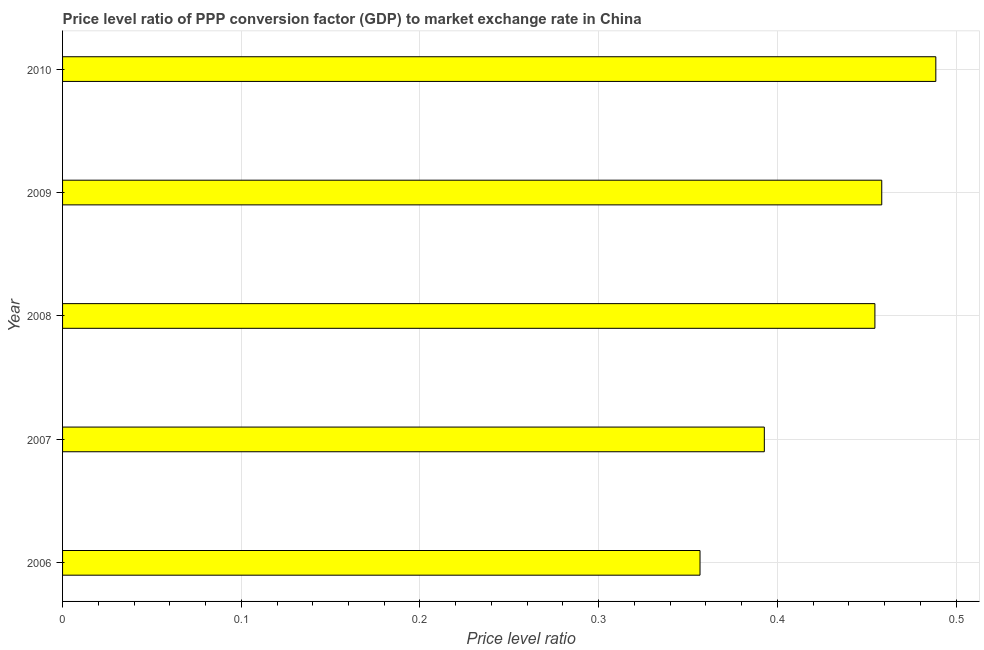Does the graph contain grids?
Keep it short and to the point. Yes. What is the title of the graph?
Give a very brief answer. Price level ratio of PPP conversion factor (GDP) to market exchange rate in China. What is the label or title of the X-axis?
Give a very brief answer. Price level ratio. What is the price level ratio in 2008?
Make the answer very short. 0.45. Across all years, what is the maximum price level ratio?
Provide a succinct answer. 0.49. Across all years, what is the minimum price level ratio?
Your answer should be compact. 0.36. In which year was the price level ratio minimum?
Offer a very short reply. 2006. What is the sum of the price level ratio?
Provide a short and direct response. 2.15. What is the difference between the price level ratio in 2007 and 2009?
Keep it short and to the point. -0.07. What is the average price level ratio per year?
Your answer should be compact. 0.43. What is the median price level ratio?
Make the answer very short. 0.45. What is the ratio of the price level ratio in 2006 to that in 2009?
Your answer should be very brief. 0.78. Is the sum of the price level ratio in 2008 and 2010 greater than the maximum price level ratio across all years?
Offer a terse response. Yes. What is the difference between the highest and the lowest price level ratio?
Ensure brevity in your answer.  0.13. How many bars are there?
Offer a very short reply. 5. Are all the bars in the graph horizontal?
Provide a succinct answer. Yes. What is the difference between two consecutive major ticks on the X-axis?
Give a very brief answer. 0.1. What is the Price level ratio in 2006?
Offer a terse response. 0.36. What is the Price level ratio of 2007?
Ensure brevity in your answer.  0.39. What is the Price level ratio of 2008?
Offer a very short reply. 0.45. What is the Price level ratio of 2009?
Provide a succinct answer. 0.46. What is the Price level ratio of 2010?
Make the answer very short. 0.49. What is the difference between the Price level ratio in 2006 and 2007?
Your response must be concise. -0.04. What is the difference between the Price level ratio in 2006 and 2008?
Your response must be concise. -0.1. What is the difference between the Price level ratio in 2006 and 2009?
Make the answer very short. -0.1. What is the difference between the Price level ratio in 2006 and 2010?
Give a very brief answer. -0.13. What is the difference between the Price level ratio in 2007 and 2008?
Provide a short and direct response. -0.06. What is the difference between the Price level ratio in 2007 and 2009?
Your response must be concise. -0.07. What is the difference between the Price level ratio in 2007 and 2010?
Your response must be concise. -0.1. What is the difference between the Price level ratio in 2008 and 2009?
Ensure brevity in your answer.  -0. What is the difference between the Price level ratio in 2008 and 2010?
Keep it short and to the point. -0.03. What is the difference between the Price level ratio in 2009 and 2010?
Offer a terse response. -0.03. What is the ratio of the Price level ratio in 2006 to that in 2007?
Keep it short and to the point. 0.91. What is the ratio of the Price level ratio in 2006 to that in 2008?
Provide a succinct answer. 0.79. What is the ratio of the Price level ratio in 2006 to that in 2009?
Ensure brevity in your answer.  0.78. What is the ratio of the Price level ratio in 2006 to that in 2010?
Your answer should be compact. 0.73. What is the ratio of the Price level ratio in 2007 to that in 2008?
Make the answer very short. 0.86. What is the ratio of the Price level ratio in 2007 to that in 2009?
Your response must be concise. 0.86. What is the ratio of the Price level ratio in 2007 to that in 2010?
Give a very brief answer. 0.8. What is the ratio of the Price level ratio in 2008 to that in 2009?
Offer a very short reply. 0.99. What is the ratio of the Price level ratio in 2009 to that in 2010?
Keep it short and to the point. 0.94. 